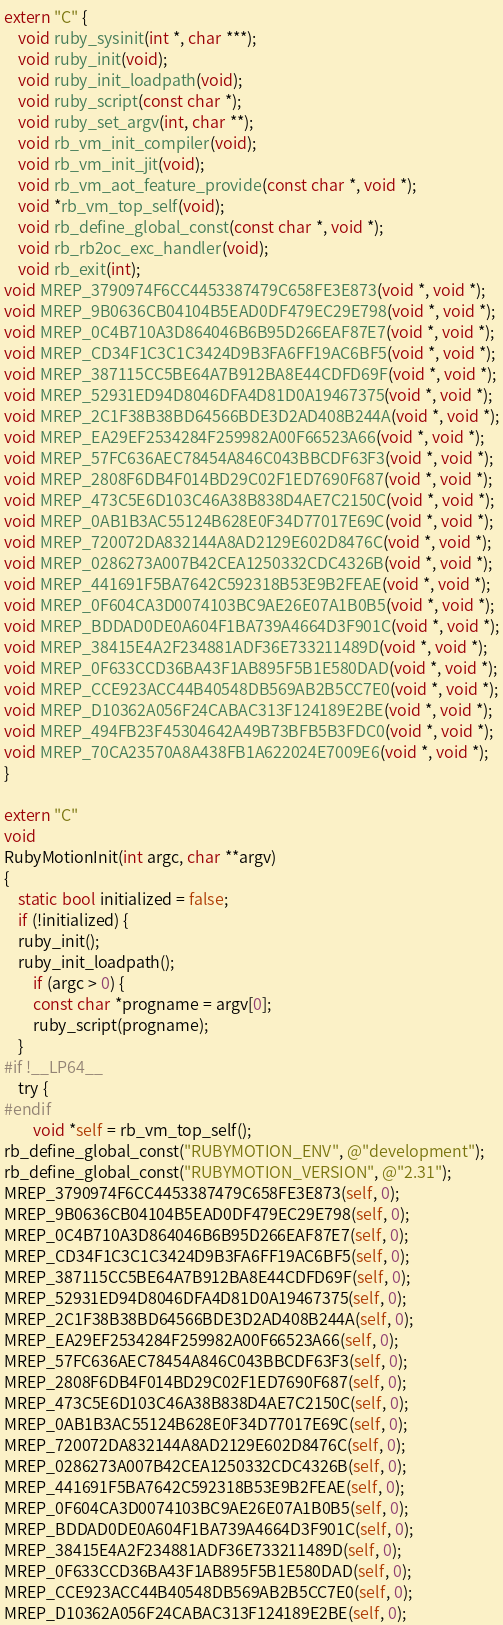<code> <loc_0><loc_0><loc_500><loc_500><_ObjectiveC_>extern "C" {
    void ruby_sysinit(int *, char ***);
    void ruby_init(void);
    void ruby_init_loadpath(void);
    void ruby_script(const char *);
    void ruby_set_argv(int, char **);
    void rb_vm_init_compiler(void);
    void rb_vm_init_jit(void);
    void rb_vm_aot_feature_provide(const char *, void *);
    void *rb_vm_top_self(void);
    void rb_define_global_const(const char *, void *);
    void rb_rb2oc_exc_handler(void);
    void rb_exit(int);
void MREP_3790974F6CC4453387479C658FE3E873(void *, void *);
void MREP_9B0636CB04104B5EAD0DF479EC29E798(void *, void *);
void MREP_0C4B710A3D864046B6B95D266EAF87E7(void *, void *);
void MREP_CD34F1C3C1C3424D9B3FA6FF19AC6BF5(void *, void *);
void MREP_387115CC5BE64A7B912BA8E44CDFD69F(void *, void *);
void MREP_52931ED94D8046DFA4D81D0A19467375(void *, void *);
void MREP_2C1F38B38BD64566BDE3D2AD408B244A(void *, void *);
void MREP_EA29EF2534284F259982A00F66523A66(void *, void *);
void MREP_57FC636AEC78454A846C043BBCDF63F3(void *, void *);
void MREP_2808F6DB4F014BD29C02F1ED7690F687(void *, void *);
void MREP_473C5E6D103C46A38B838D4AE7C2150C(void *, void *);
void MREP_0AB1B3AC55124B628E0F34D77017E69C(void *, void *);
void MREP_720072DA832144A8AD2129E602D8476C(void *, void *);
void MREP_0286273A007B42CEA1250332CDC4326B(void *, void *);
void MREP_441691F5BA7642C592318B53E9B2FEAE(void *, void *);
void MREP_0F604CA3D0074103BC9AE26E07A1B0B5(void *, void *);
void MREP_BDDAD0DE0A604F1BA739A4664D3F901C(void *, void *);
void MREP_38415E4A2F234881ADF36E733211489D(void *, void *);
void MREP_0F633CCD36BA43F1AB895F5B1E580DAD(void *, void *);
void MREP_CCE923ACC44B40548DB569AB2B5CC7E0(void *, void *);
void MREP_D10362A056F24CABAC313F124189E2BE(void *, void *);
void MREP_494FB23F45304642A49B73BFB5B3FDC0(void *, void *);
void MREP_70CA23570A8A438FB1A622024E7009E6(void *, void *);
}

extern "C"
void
RubyMotionInit(int argc, char **argv)
{
    static bool initialized = false;
    if (!initialized) {
	ruby_init();
	ruby_init_loadpath();
        if (argc > 0) {
	    const char *progname = argv[0];
	    ruby_script(progname);
	}
#if !__LP64__
	try {
#endif
	    void *self = rb_vm_top_self();
rb_define_global_const("RUBYMOTION_ENV", @"development");
rb_define_global_const("RUBYMOTION_VERSION", @"2.31");
MREP_3790974F6CC4453387479C658FE3E873(self, 0);
MREP_9B0636CB04104B5EAD0DF479EC29E798(self, 0);
MREP_0C4B710A3D864046B6B95D266EAF87E7(self, 0);
MREP_CD34F1C3C1C3424D9B3FA6FF19AC6BF5(self, 0);
MREP_387115CC5BE64A7B912BA8E44CDFD69F(self, 0);
MREP_52931ED94D8046DFA4D81D0A19467375(self, 0);
MREP_2C1F38B38BD64566BDE3D2AD408B244A(self, 0);
MREP_EA29EF2534284F259982A00F66523A66(self, 0);
MREP_57FC636AEC78454A846C043BBCDF63F3(self, 0);
MREP_2808F6DB4F014BD29C02F1ED7690F687(self, 0);
MREP_473C5E6D103C46A38B838D4AE7C2150C(self, 0);
MREP_0AB1B3AC55124B628E0F34D77017E69C(self, 0);
MREP_720072DA832144A8AD2129E602D8476C(self, 0);
MREP_0286273A007B42CEA1250332CDC4326B(self, 0);
MREP_441691F5BA7642C592318B53E9B2FEAE(self, 0);
MREP_0F604CA3D0074103BC9AE26E07A1B0B5(self, 0);
MREP_BDDAD0DE0A604F1BA739A4664D3F901C(self, 0);
MREP_38415E4A2F234881ADF36E733211489D(self, 0);
MREP_0F633CCD36BA43F1AB895F5B1E580DAD(self, 0);
MREP_CCE923ACC44B40548DB569AB2B5CC7E0(self, 0);
MREP_D10362A056F24CABAC313F124189E2BE(self, 0);</code> 